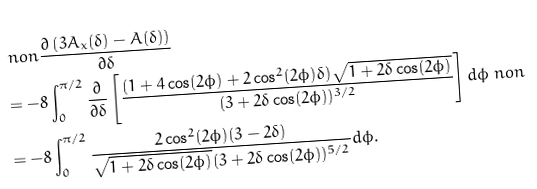Convert formula to latex. <formula><loc_0><loc_0><loc_500><loc_500>& \ n o n \frac { \partial \left ( 3 A _ { x } ( \delta ) - A ( \delta ) \right ) } { \partial \delta } \\ & = - 8 \int _ { 0 } ^ { \pi / 2 } \frac { \partial } { \partial \delta } \left [ \frac { ( 1 + 4 \cos ( 2 \phi ) + 2 \cos ^ { 2 } ( 2 \phi ) \delta ) \sqrt { 1 + 2 \delta \cos ( 2 \phi ) } } { ( 3 + 2 \delta \cos ( 2 \phi ) ) ^ { 3 / 2 } } \right ] d \phi \ n o n \\ & = - 8 \int _ { 0 } ^ { \pi / 2 } \frac { 2 \cos ^ { 2 } ( 2 \phi ) ( 3 - 2 \delta ) } { \sqrt { 1 + 2 \delta \cos ( 2 \phi ) } ( 3 + 2 \delta \cos ( 2 \phi ) ) ^ { 5 / 2 } } d \phi .</formula> 